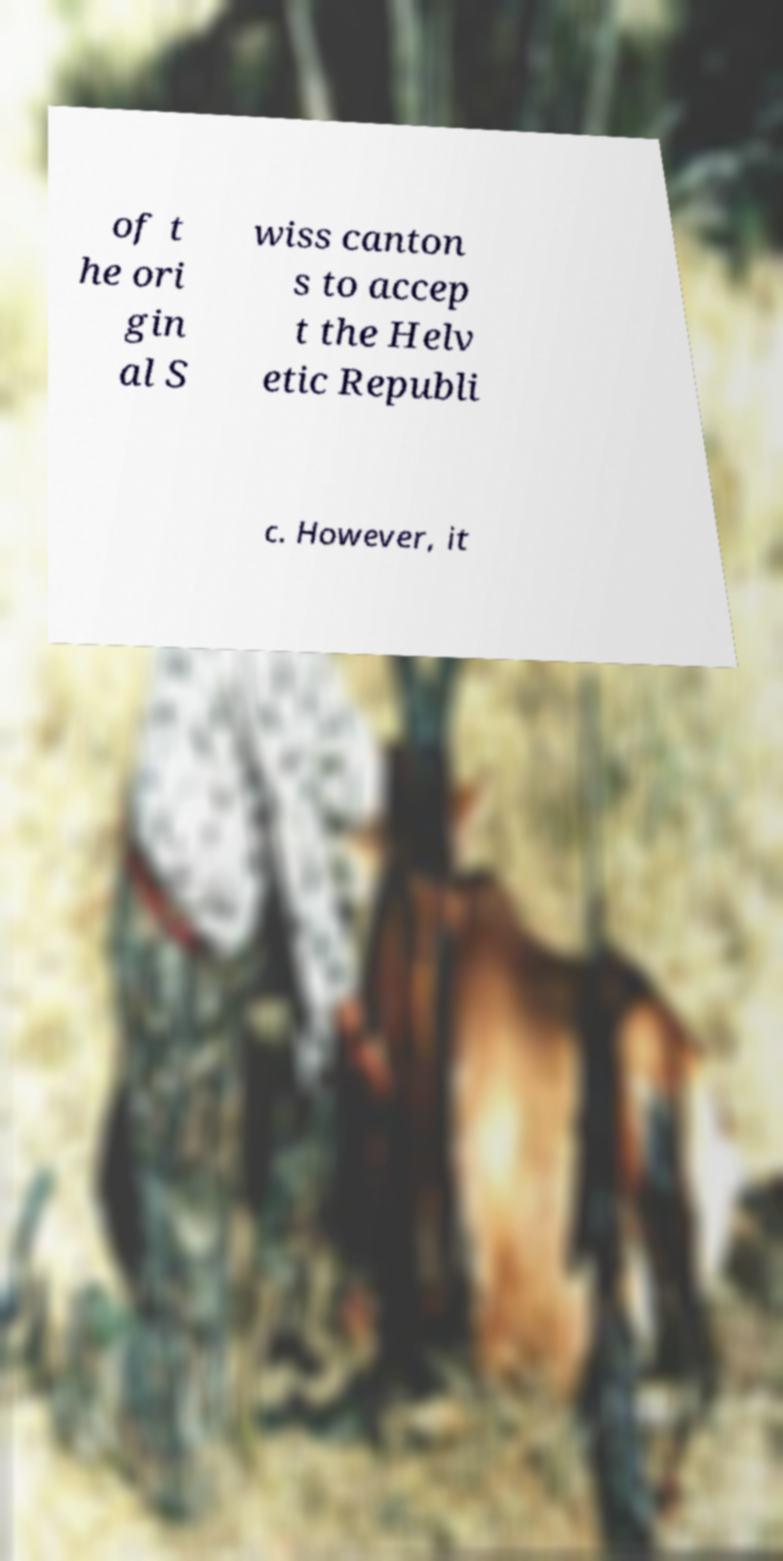Can you accurately transcribe the text from the provided image for me? of t he ori gin al S wiss canton s to accep t the Helv etic Republi c. However, it 